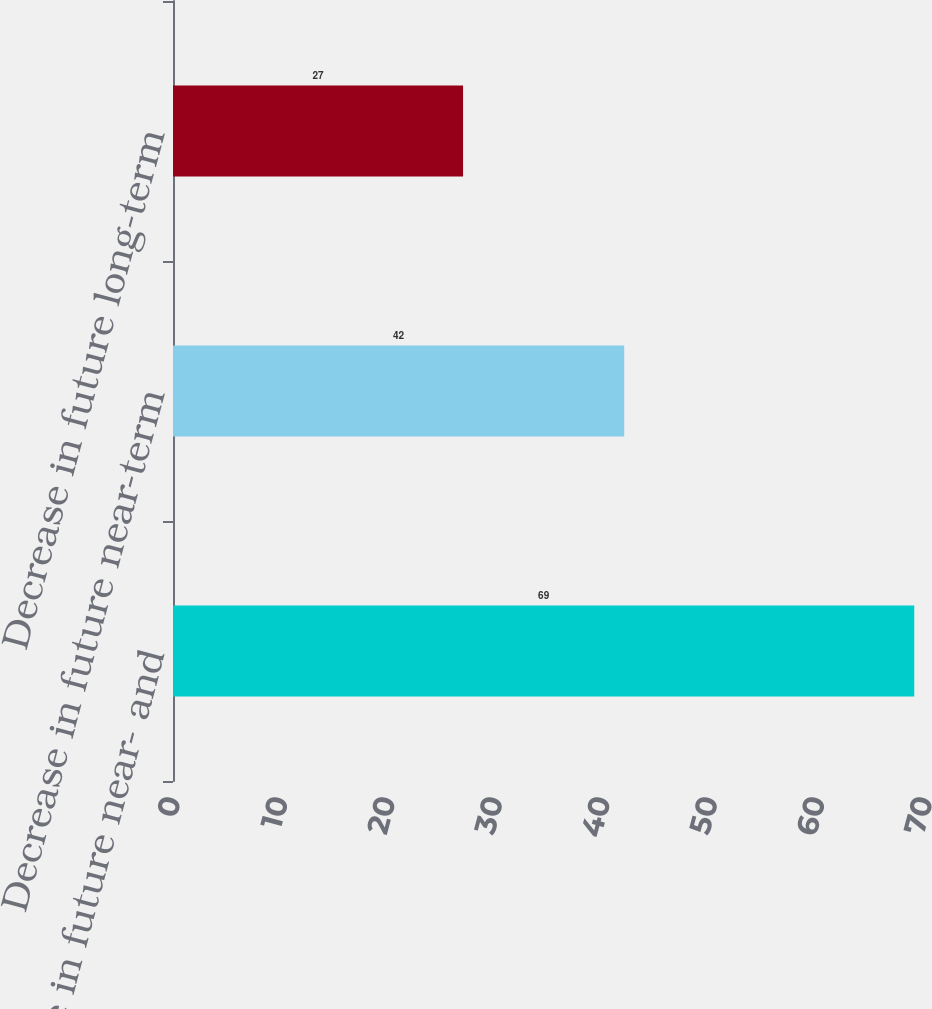Convert chart to OTSL. <chart><loc_0><loc_0><loc_500><loc_500><bar_chart><fcel>Decrease in future near- and<fcel>Decrease in future near-term<fcel>Decrease in future long-term<nl><fcel>69<fcel>42<fcel>27<nl></chart> 